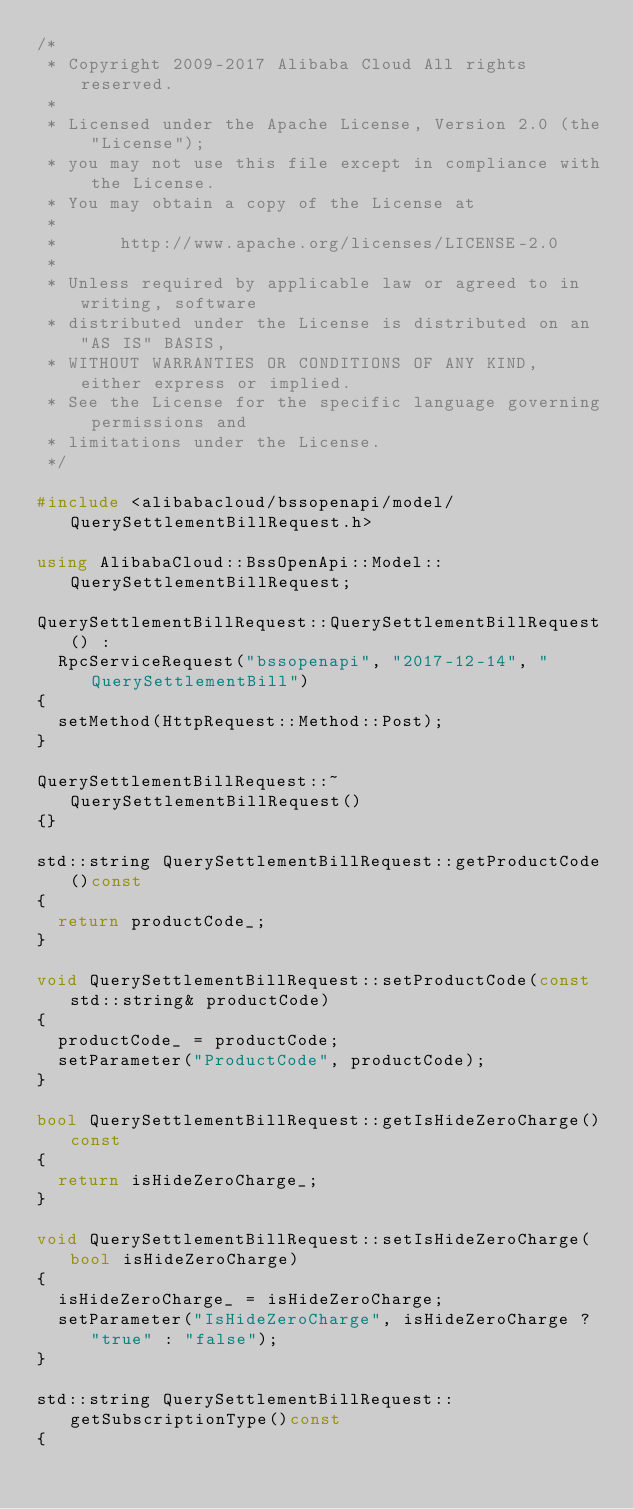<code> <loc_0><loc_0><loc_500><loc_500><_C++_>/*
 * Copyright 2009-2017 Alibaba Cloud All rights reserved.
 * 
 * Licensed under the Apache License, Version 2.0 (the "License");
 * you may not use this file except in compliance with the License.
 * You may obtain a copy of the License at
 * 
 *      http://www.apache.org/licenses/LICENSE-2.0
 * 
 * Unless required by applicable law or agreed to in writing, software
 * distributed under the License is distributed on an "AS IS" BASIS,
 * WITHOUT WARRANTIES OR CONDITIONS OF ANY KIND, either express or implied.
 * See the License for the specific language governing permissions and
 * limitations under the License.
 */

#include <alibabacloud/bssopenapi/model/QuerySettlementBillRequest.h>

using AlibabaCloud::BssOpenApi::Model::QuerySettlementBillRequest;

QuerySettlementBillRequest::QuerySettlementBillRequest() :
	RpcServiceRequest("bssopenapi", "2017-12-14", "QuerySettlementBill")
{
	setMethod(HttpRequest::Method::Post);
}

QuerySettlementBillRequest::~QuerySettlementBillRequest()
{}

std::string QuerySettlementBillRequest::getProductCode()const
{
	return productCode_;
}

void QuerySettlementBillRequest::setProductCode(const std::string& productCode)
{
	productCode_ = productCode;
	setParameter("ProductCode", productCode);
}

bool QuerySettlementBillRequest::getIsHideZeroCharge()const
{
	return isHideZeroCharge_;
}

void QuerySettlementBillRequest::setIsHideZeroCharge(bool isHideZeroCharge)
{
	isHideZeroCharge_ = isHideZeroCharge;
	setParameter("IsHideZeroCharge", isHideZeroCharge ? "true" : "false");
}

std::string QuerySettlementBillRequest::getSubscriptionType()const
{</code> 